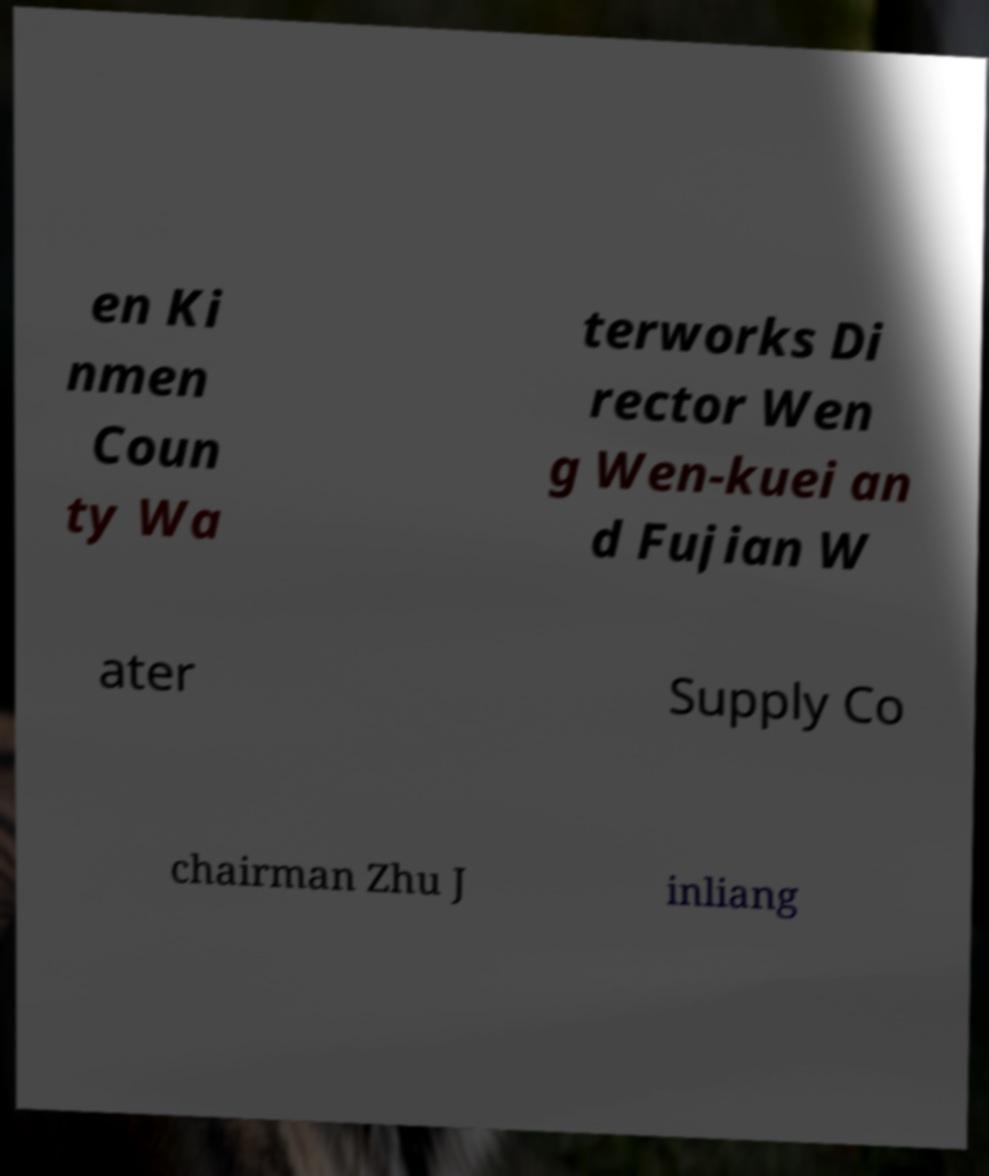Could you assist in decoding the text presented in this image and type it out clearly? en Ki nmen Coun ty Wa terworks Di rector Wen g Wen-kuei an d Fujian W ater Supply Co chairman Zhu J inliang 